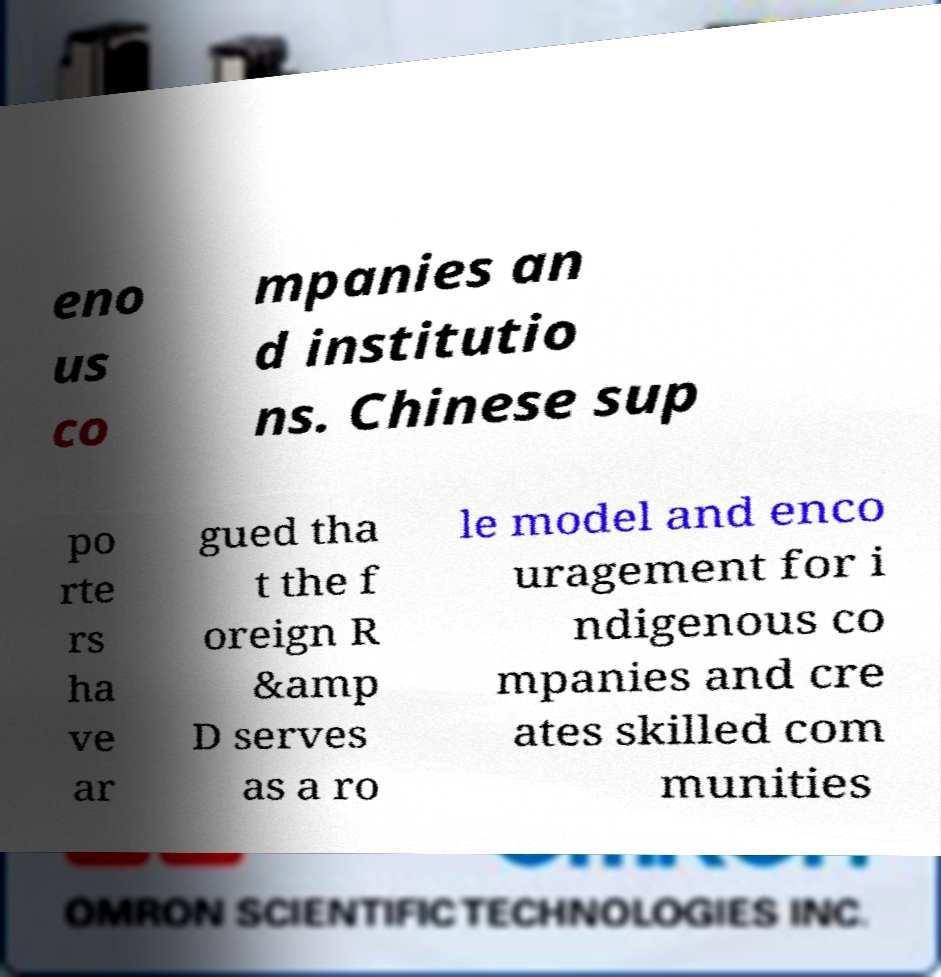What messages or text are displayed in this image? I need them in a readable, typed format. eno us co mpanies an d institutio ns. Chinese sup po rte rs ha ve ar gued tha t the f oreign R &amp D serves as a ro le model and enco uragement for i ndigenous co mpanies and cre ates skilled com munities 